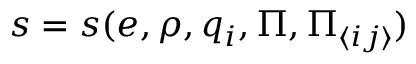Convert formula to latex. <formula><loc_0><loc_0><loc_500><loc_500>s = s ( e , \rho , q _ { i } , \Pi , \Pi _ { \langle i j \rangle } )</formula> 